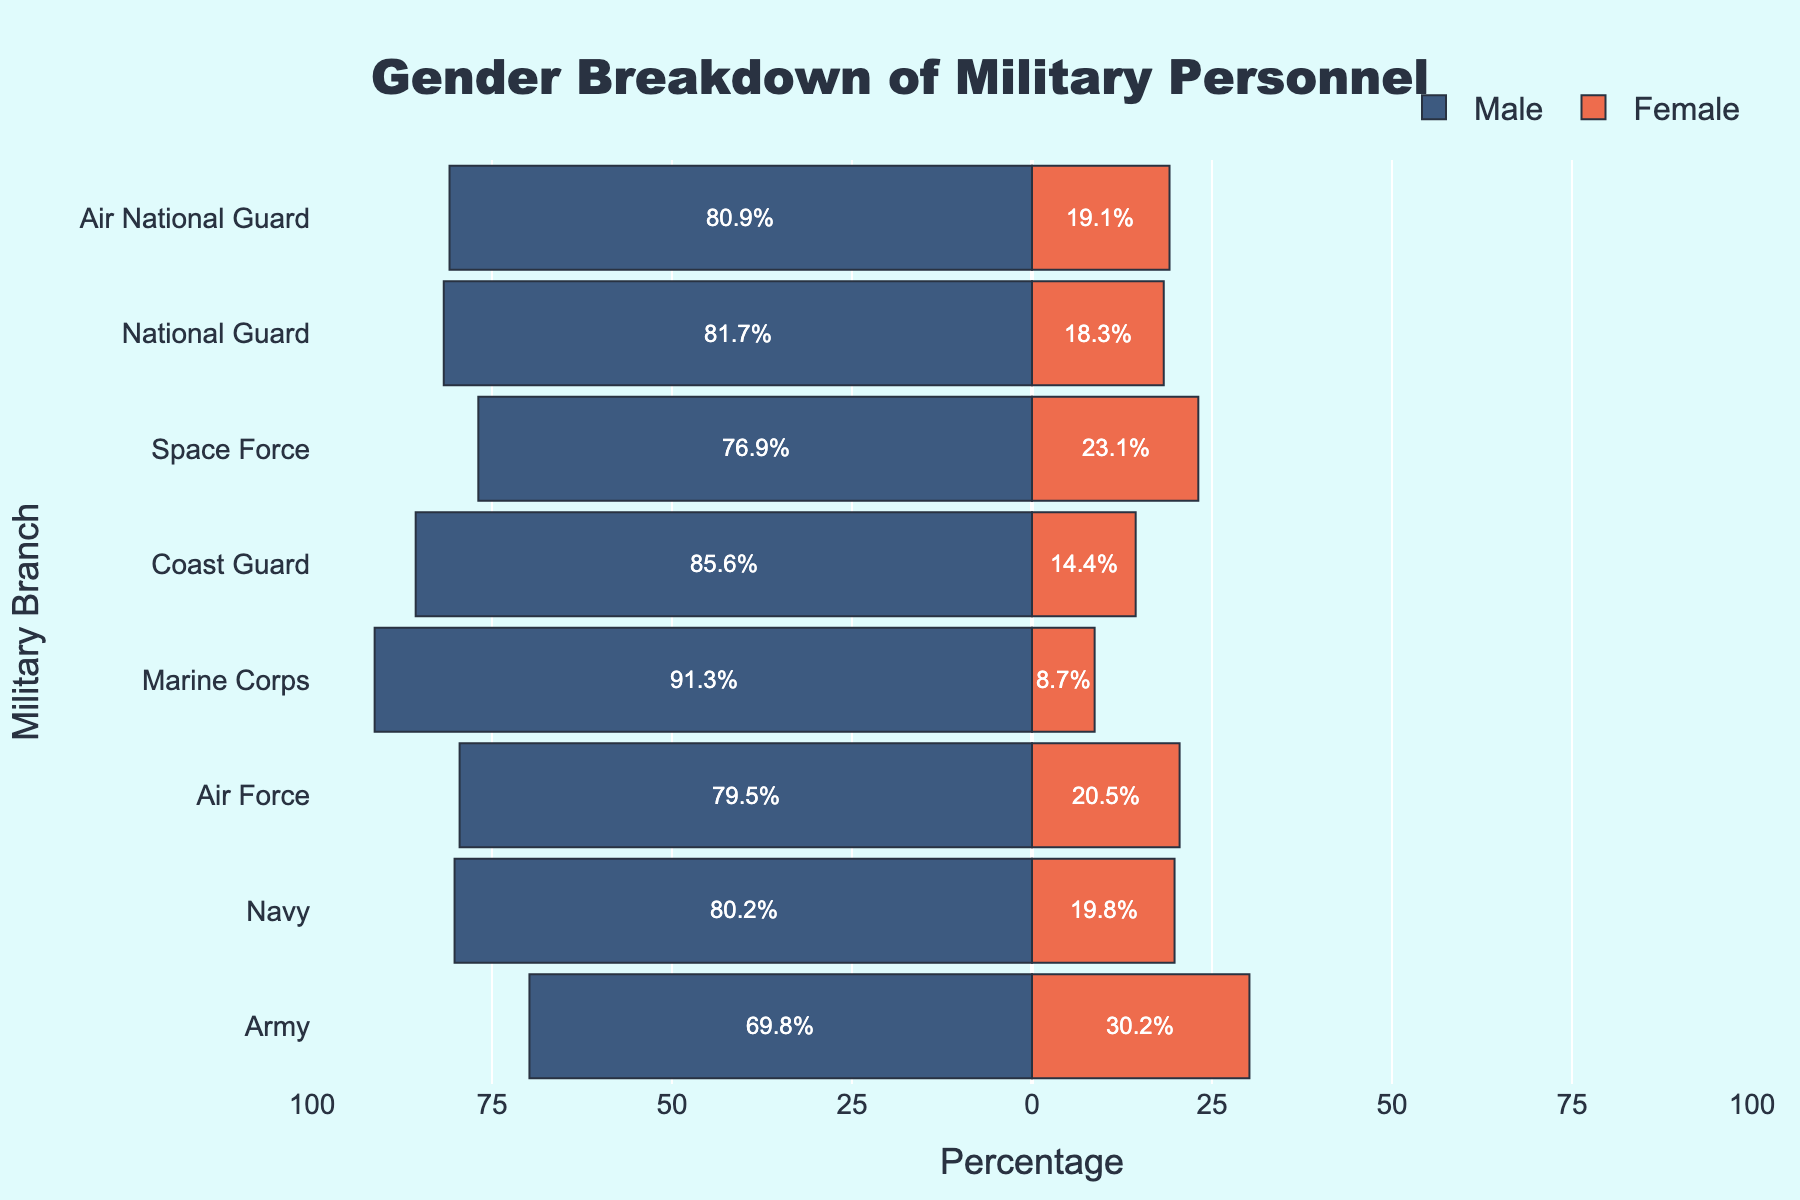Which branch has the highest percentage of female personnel? To find this, look at the lengths of the bars representing female percentages for each branch. The Army has the longest bar in the female category, indicating it has the highest percentage.
Answer: Army Which branch has the lowest percentage of male personnel? To identify this, examine the bars representing male percentages, noting the shortest bar. The Army has the shortest bar in the male category.
Answer: Army What is the title of the figure? The title is prominently displayed at the top of the figure.
Answer: Gender Breakdown of Military Personnel Which branch shows the greatest disparity between male and female personnel percentages? Calculate the difference between male and female percentages for each branch. The Marine Corps has the largest difference, with a male percentage of 91.3% and a female percentage of 8.7%, making the disparity 82.6%.
Answer: Marine Corps How does the percentage of male personnel in the Navy compare to that in the Air Force? Compare the lengths of the bars representing male percentages for the Navy and Air Force. The Navy has a male percentage of 80.2%, and the Air Force has 79.5%. The difference is 0.7%.
Answer: Navy is higher by 0.7% What is the combined percentage of female personnel in the Air Force and Space Force? Sum the female percentages of the Air Force and Space Force. 20.5% (Air Force) + 23.1% (Space Force) = 43.6%.
Answer: 43.6% What are the primary colors used to represent male and female categories in the figure? The colors are visually distinct; male categories are in a shade of blue, and female categories in a shade of red.
Answer: Blue for male, red for female Which branch has nearly balanced male and female personnel ratios? Look for branches where both the male and female bars are relatively even. The Army comes closest with 69.8% male and 30.2% female.
Answer: Army What is the percentage difference between male and female personnel in the Coast Guard? Subtract the female percentage from the male percentage in the Coast Guard. 85.6% (male) - 14.4% (female) = 71.2%.
Answer: 71.2% 